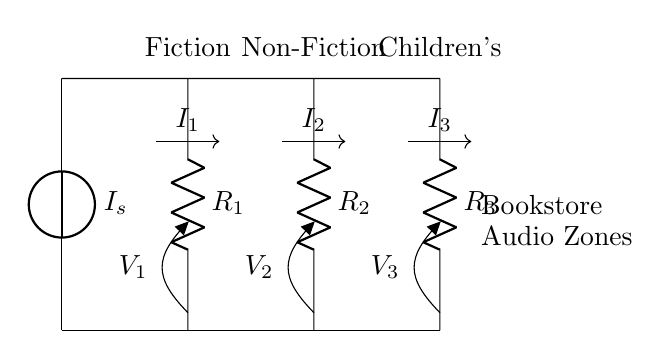What is the total current supplied in the circuit? The total current supplied is given by the source labeled as 'I_s' at the top of the circuit.
Answer: I_s What are the resistance values in the circuit? The resistances are labeled 'R_1', 'R_2', and 'R_3'. Each is the resistance for its respective audio zone in the bookstore: Fiction, Non-Fiction, and Children's.
Answer: R_1, R_2, R_3 How many audio zones are represented in this circuit? The circuit diagram displays three audio zones: Fiction, Non-Fiction, and Children's. This can be determined by identifying the separate branches connected to the current divider.
Answer: 3 What is the significance of the nodes labeled 'V_1', 'V_2', and 'V_3'? These nodes represent the voltage drops across each resistor, allowing us to measure the voltage for each audio zone separately in the circuit.
Answer: Voltage drops Which resistor would have the highest current if all resistors have the same value? If all resistors are equal, the current will divide evenly among them; thus, each would have the same current, making it impossible to identify a single resistor with the highest current without changing resistance values.
Answer: None How does the current divider operate in this circuit? The current divider formula indicates that the total current splits inversely proportional to the resistance values in parallel; the smaller the resistance, the larger the current through that branch.
Answer: Inversely proportional 